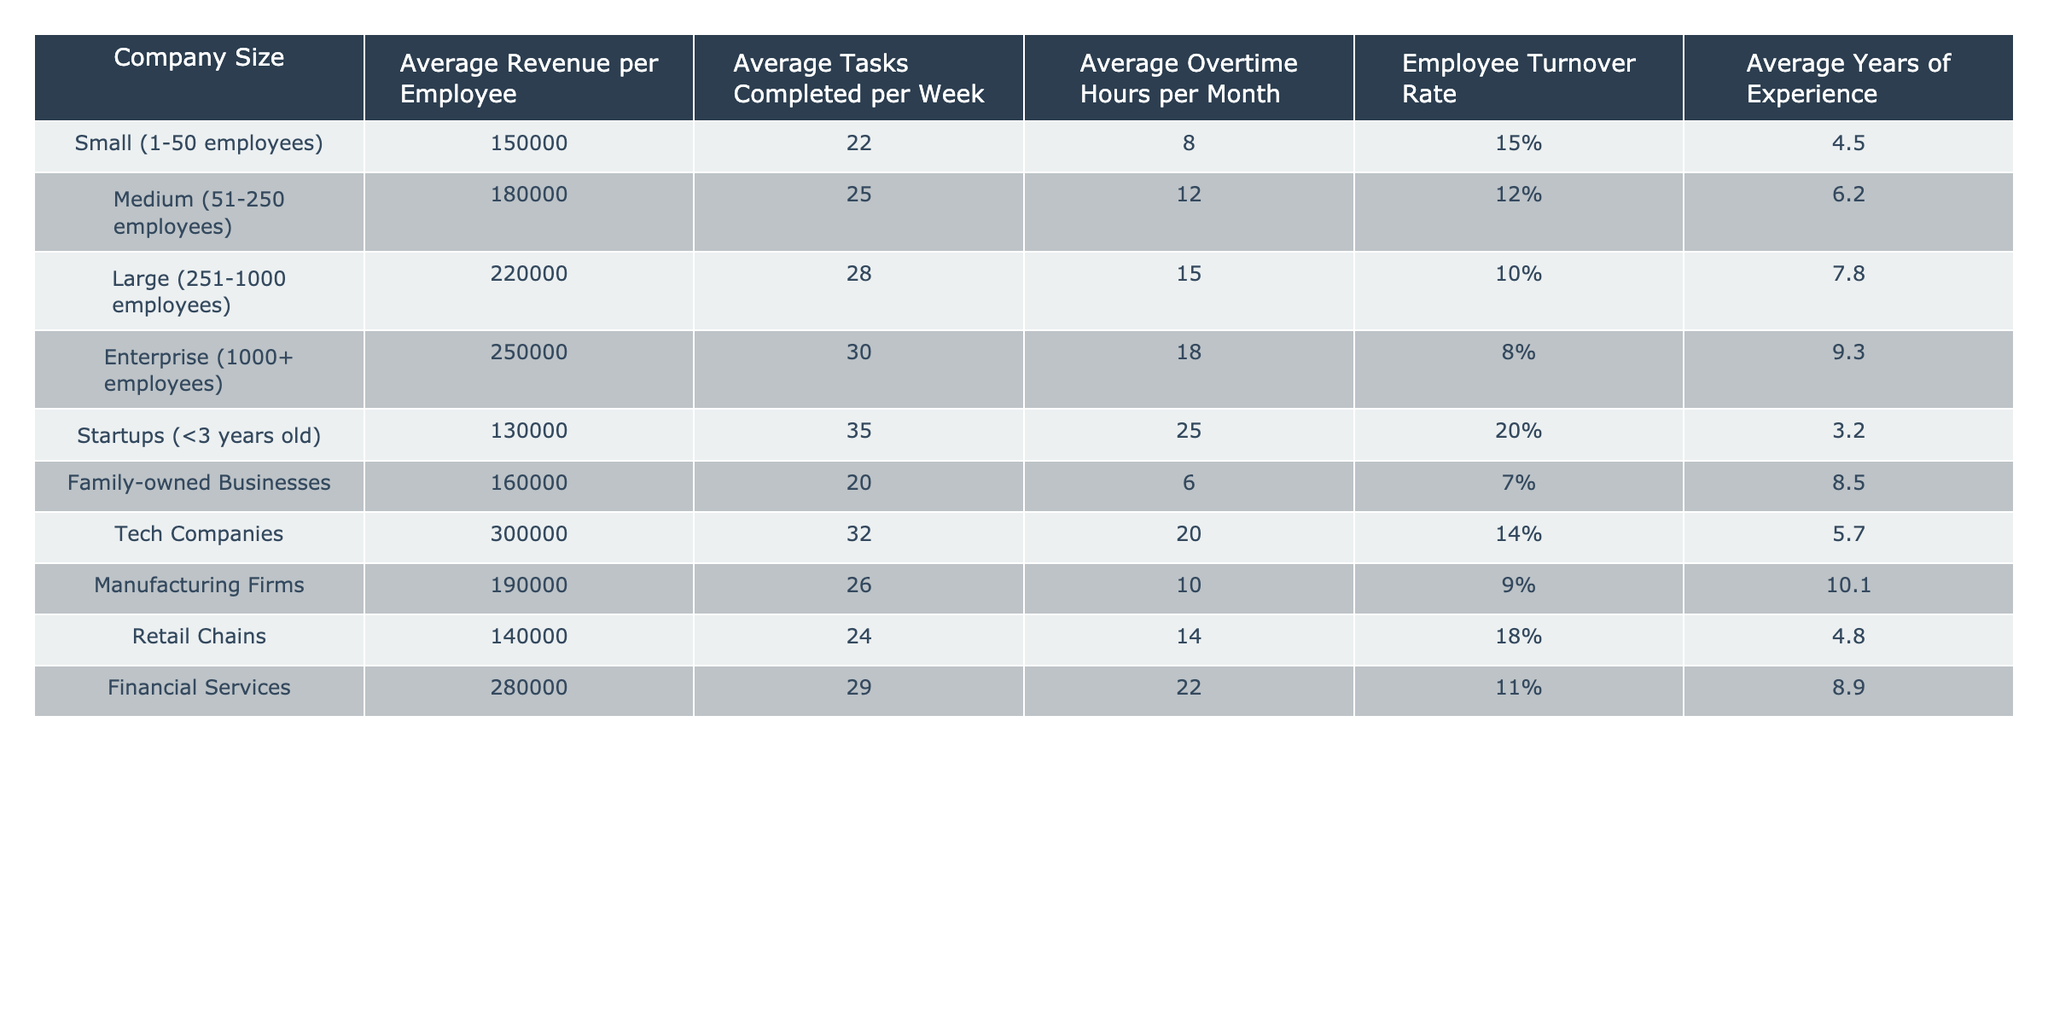What is the average revenue per employee for medium-sized companies? The average revenue per employee for medium-sized companies, which are categorized as having 51-250 employees, is listed directly in the table. It is 180,000.
Answer: 180000 Which company size has the highest average tasks completed per week? By examining the values under "Average Tasks Completed per Week," the row for startups shows the highest number at 35.
Answer: Startups (<3 years old) What is the employee turnover rate for large companies? The employee turnover rate for large companies, categorized as having 251-1000 employees, is visible in the table and is listed as 10%.
Answer: 10% What is the difference in average revenue per employee between tech companies and retail chains? The average revenue per employee for tech companies is 300,000, and for retail chains it is 140,000. The difference is calculated as 300,000 - 140,000 = 160,000.
Answer: 160000 Is the average years of experience higher in family-owned businesses than in startups? The average years of experience for family-owned businesses is 8.5 years, while for startups it is 3.2 years. Since 8.5 > 3.2, the answer is yes.
Answer: Yes What is the average overtime hours per month for medium-sized and large companies combined? First, we find the average overtime hours for medium-sized (12) and large companies (15). Then, we calculate the average for both: (12 + 15) / 2 = 13.5.
Answer: 13.5 Which company size has the lowest employee turnover rate? Examining the "Employee Turnover Rate" column, family-owned businesses have the lowest rate listed as 7%.
Answer: Family-owned Businesses If we consider only manufacturing firms and tech companies, what is their average tasks completed per week? The average tasks completed per week for manufacturing firms is 26 and for tech companies, it is 32. The average of these two values is calculated as (26 + 32) / 2 = 29.
Answer: 29 What percentage of companies have an average revenue per employee greater than 200,000? We can analyze the revenue values and see that large companies (220,000), enterprise (250,000), and tech companies (300,000) all have revenues greater than 200,000. This gives us 4 out of 10 companies, resulting in (4/10) * 100 = 40%.
Answer: 40% Is it true that startups have the highest average overtime hours per month? Startups report an average of 25 overtime hours per month, which is more than the numbers reported by all other company sizes. Therefore, the statement is true.
Answer: True 